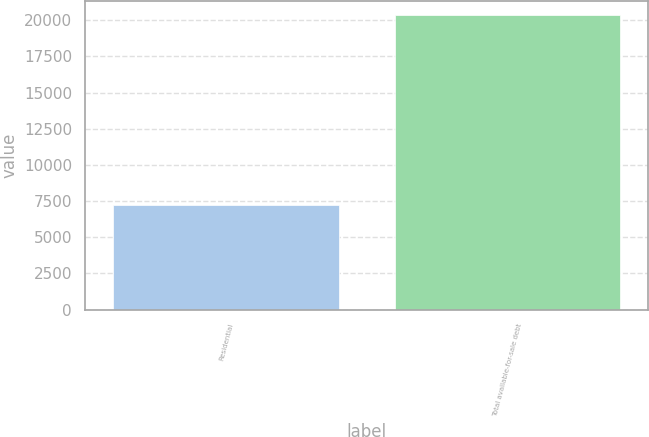Convert chart to OTSL. <chart><loc_0><loc_0><loc_500><loc_500><bar_chart><fcel>Residential<fcel>Total available-for-sale debt<nl><fcel>7216<fcel>20346<nl></chart> 